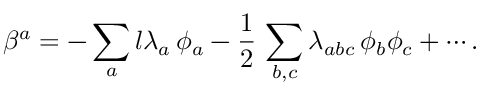<formula> <loc_0><loc_0><loc_500><loc_500>\beta ^ { a } = - \sum _ { a } l \lambda _ { a } \, \phi _ { a } - \frac { 1 } { 2 } \, \sum _ { b , c } \lambda _ { a b c } \, \phi _ { b } \phi _ { c } + \cdots .</formula> 